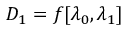<formula> <loc_0><loc_0><loc_500><loc_500>D _ { 1 } = f [ \lambda _ { 0 } , \lambda _ { 1 } ]</formula> 